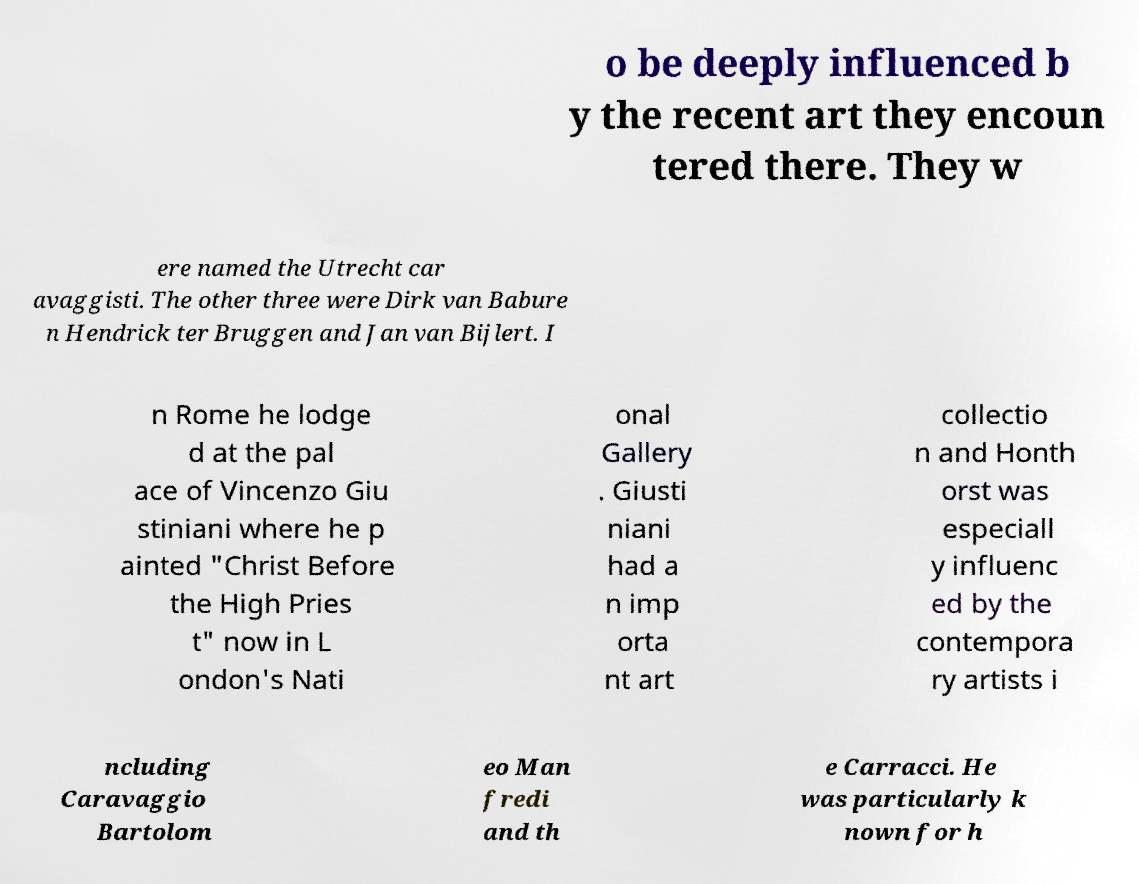For documentation purposes, I need the text within this image transcribed. Could you provide that? o be deeply influenced b y the recent art they encoun tered there. They w ere named the Utrecht car avaggisti. The other three were Dirk van Babure n Hendrick ter Bruggen and Jan van Bijlert. I n Rome he lodge d at the pal ace of Vincenzo Giu stiniani where he p ainted "Christ Before the High Pries t" now in L ondon's Nati onal Gallery . Giusti niani had a n imp orta nt art collectio n and Honth orst was especiall y influenc ed by the contempora ry artists i ncluding Caravaggio Bartolom eo Man fredi and th e Carracci. He was particularly k nown for h 